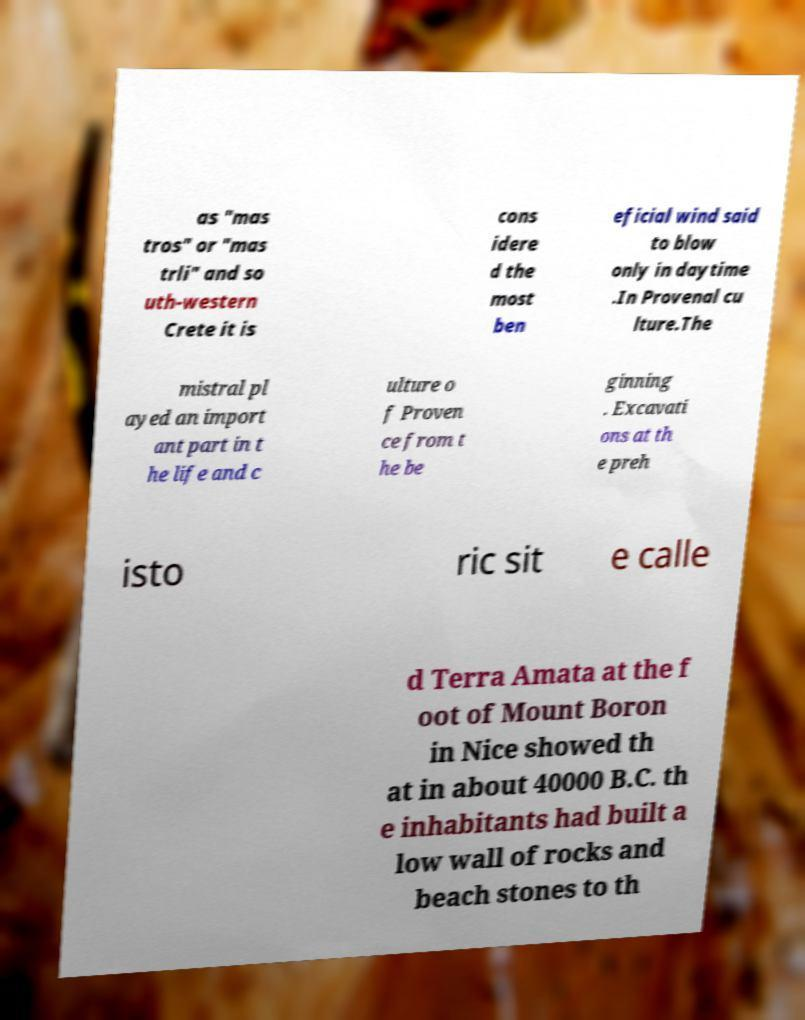Can you read and provide the text displayed in the image?This photo seems to have some interesting text. Can you extract and type it out for me? as "mas tros" or "mas trli" and so uth-western Crete it is cons idere d the most ben eficial wind said to blow only in daytime .In Provenal cu lture.The mistral pl ayed an import ant part in t he life and c ulture o f Proven ce from t he be ginning . Excavati ons at th e preh isto ric sit e calle d Terra Amata at the f oot of Mount Boron in Nice showed th at in about 40000 B.C. th e inhabitants had built a low wall of rocks and beach stones to th 